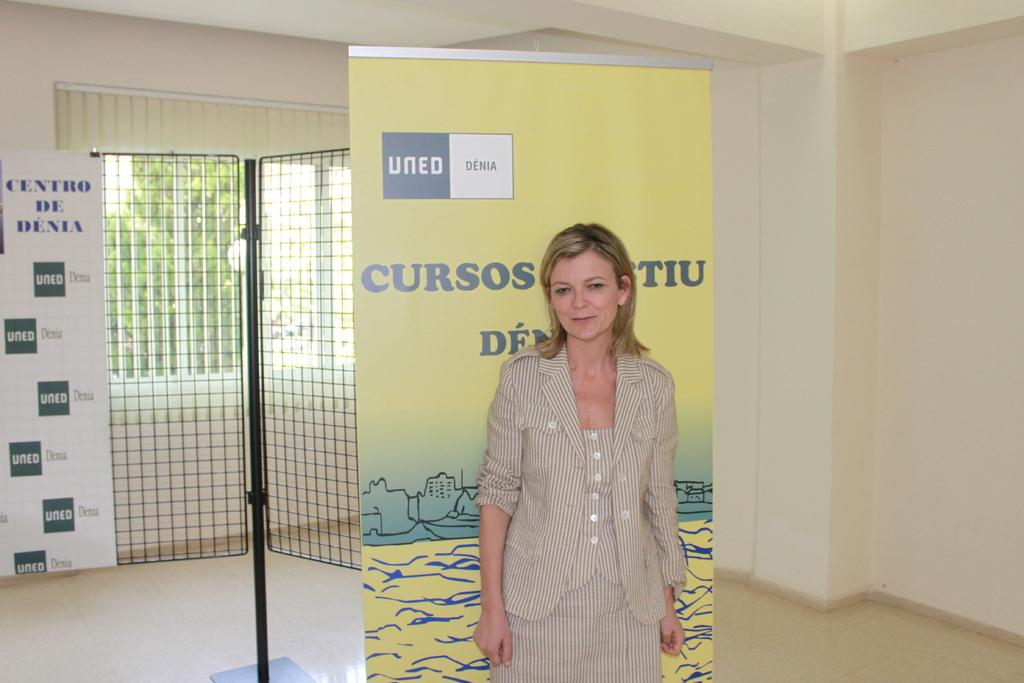Who is present in the image? There is a lady in the image. What is the main object in the foreground of the image? There is a board in the image. What can be seen in the background of the image? There is a board, a rod with grille, a wall, and other objects in the background of the image. What part of the room is visible at the top of the image? The ceiling is visible at the top of the image. What time does the clock in the image show? There is no clock present in the image. How many babies are visible in the image? There are no babies present in the image. 